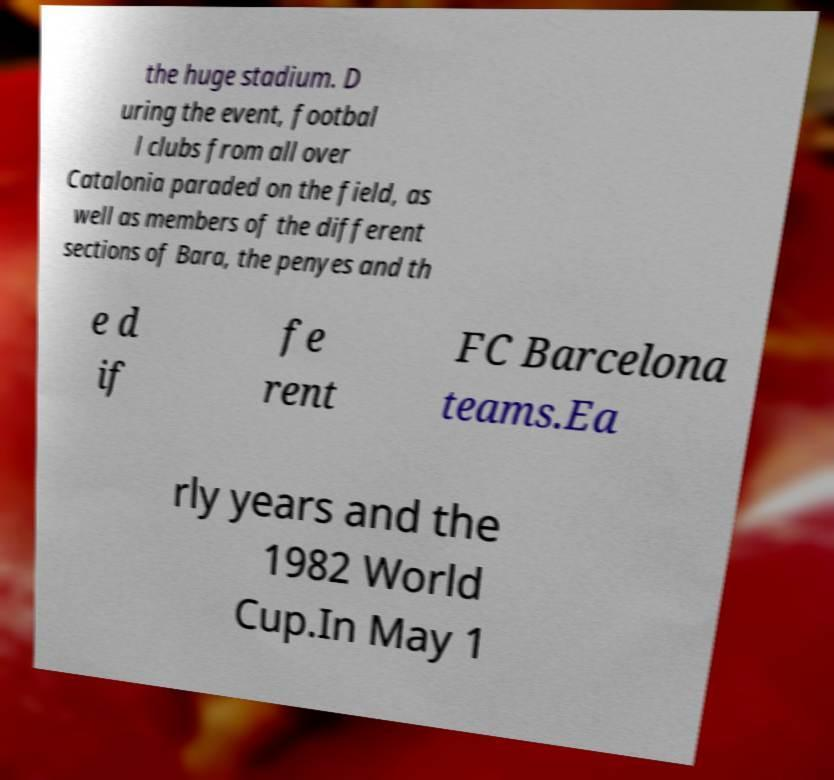Could you extract and type out the text from this image? the huge stadium. D uring the event, footbal l clubs from all over Catalonia paraded on the field, as well as members of the different sections of Bara, the penyes and th e d if fe rent FC Barcelona teams.Ea rly years and the 1982 World Cup.In May 1 